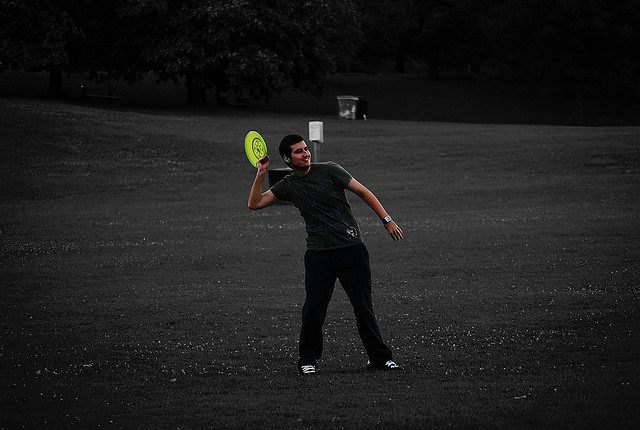Describe the objects in this image and their specific colors. I can see people in black, maroon, gray, and brown tones and frisbee in black, olive, and khaki tones in this image. 